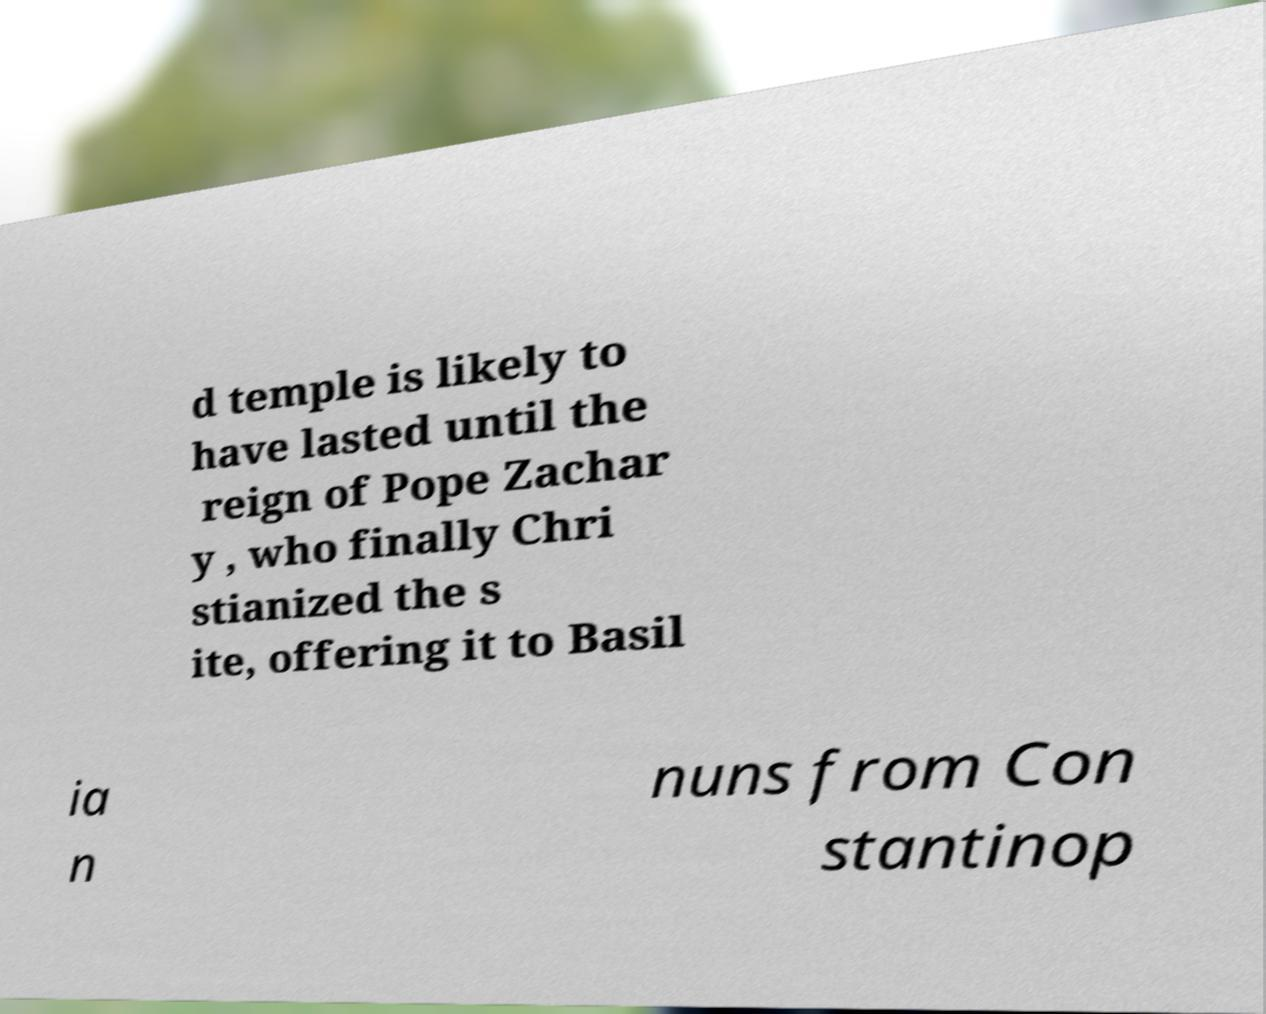There's text embedded in this image that I need extracted. Can you transcribe it verbatim? d temple is likely to have lasted until the reign of Pope Zachar y , who finally Chri stianized the s ite, offering it to Basil ia n nuns from Con stantinop 